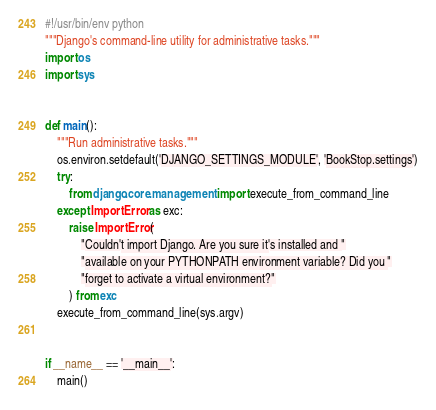Convert code to text. <code><loc_0><loc_0><loc_500><loc_500><_Python_>#!/usr/bin/env python
"""Django's command-line utility for administrative tasks."""
import os
import sys


def main():
    """Run administrative tasks."""
    os.environ.setdefault('DJANGO_SETTINGS_MODULE', 'BookStop.settings')
    try:
        from django.core.management import execute_from_command_line
    except ImportError as exc:
        raise ImportError(
            "Couldn't import Django. Are you sure it's installed and "
            "available on your PYTHONPATH environment variable? Did you "
            "forget to activate a virtual environment?"
        ) from exc
    execute_from_command_line(sys.argv)


if __name__ == '__main__':
    main()
</code> 